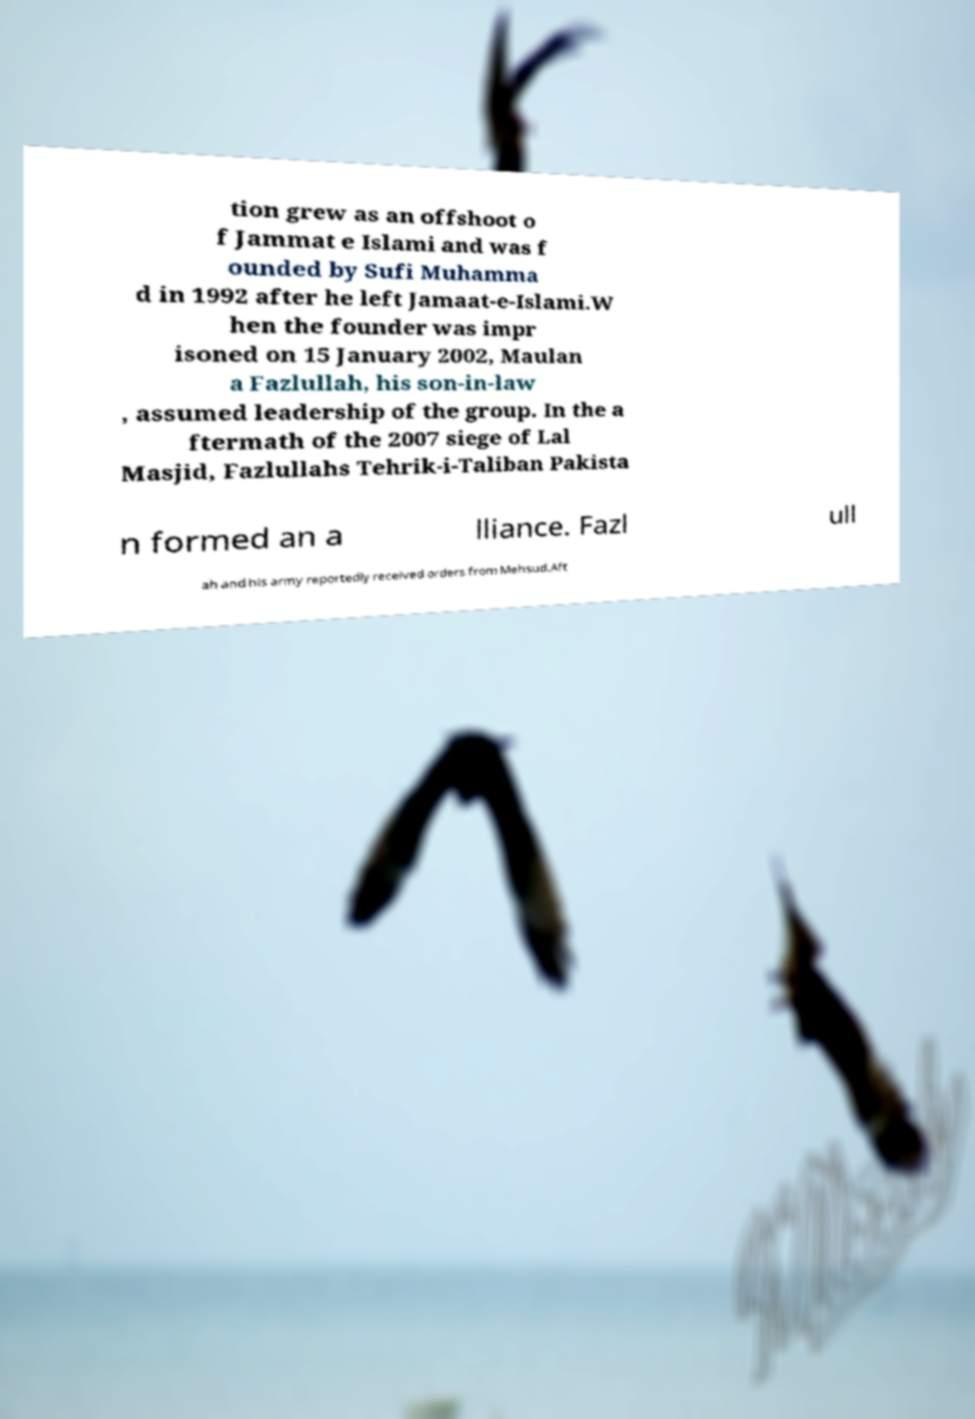Please identify and transcribe the text found in this image. tion grew as an offshoot o f Jammat e Islami and was f ounded by Sufi Muhamma d in 1992 after he left Jamaat-e-Islami.W hen the founder was impr isoned on 15 January 2002, Maulan a Fazlullah, his son-in-law , assumed leadership of the group. In the a ftermath of the 2007 siege of Lal Masjid, Fazlullahs Tehrik-i-Taliban Pakista n formed an a lliance. Fazl ull ah and his army reportedly received orders from Mehsud.Aft 